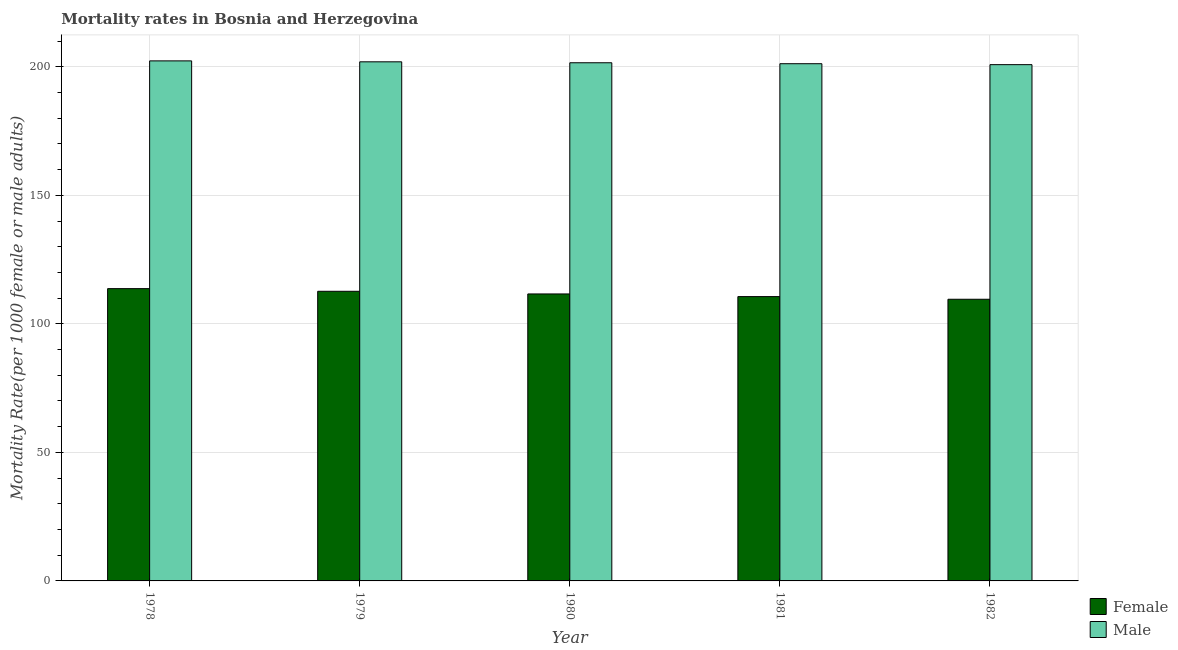How many different coloured bars are there?
Offer a terse response. 2. What is the label of the 4th group of bars from the left?
Give a very brief answer. 1981. In how many cases, is the number of bars for a given year not equal to the number of legend labels?
Offer a terse response. 0. What is the male mortality rate in 1978?
Your answer should be compact. 202.32. Across all years, what is the maximum female mortality rate?
Offer a very short reply. 113.71. Across all years, what is the minimum male mortality rate?
Your answer should be very brief. 200.85. In which year was the male mortality rate maximum?
Make the answer very short. 1978. What is the total male mortality rate in the graph?
Ensure brevity in your answer.  1007.91. What is the difference between the female mortality rate in 1978 and that in 1979?
Offer a terse response. 1.03. What is the difference between the male mortality rate in 1981 and the female mortality rate in 1979?
Ensure brevity in your answer.  -0.73. What is the average male mortality rate per year?
Your answer should be very brief. 201.58. In the year 1982, what is the difference between the female mortality rate and male mortality rate?
Provide a succinct answer. 0. What is the ratio of the female mortality rate in 1978 to that in 1980?
Your response must be concise. 1.02. Is the female mortality rate in 1978 less than that in 1979?
Offer a very short reply. No. What is the difference between the highest and the second highest male mortality rate?
Your response must be concise. 0.37. What is the difference between the highest and the lowest female mortality rate?
Provide a succinct answer. 4.13. In how many years, is the female mortality rate greater than the average female mortality rate taken over all years?
Your response must be concise. 3. Is the sum of the male mortality rate in 1981 and 1982 greater than the maximum female mortality rate across all years?
Your response must be concise. Yes. What does the 1st bar from the right in 1979 represents?
Make the answer very short. Male. How many bars are there?
Offer a terse response. 10. Are all the bars in the graph horizontal?
Make the answer very short. No. What is the difference between two consecutive major ticks on the Y-axis?
Make the answer very short. 50. Where does the legend appear in the graph?
Provide a succinct answer. Bottom right. How many legend labels are there?
Your response must be concise. 2. What is the title of the graph?
Ensure brevity in your answer.  Mortality rates in Bosnia and Herzegovina. Does "Secondary education" appear as one of the legend labels in the graph?
Provide a short and direct response. No. What is the label or title of the Y-axis?
Provide a succinct answer. Mortality Rate(per 1000 female or male adults). What is the Mortality Rate(per 1000 female or male adults) of Female in 1978?
Your answer should be very brief. 113.71. What is the Mortality Rate(per 1000 female or male adults) of Male in 1978?
Make the answer very short. 202.32. What is the Mortality Rate(per 1000 female or male adults) of Female in 1979?
Offer a terse response. 112.68. What is the Mortality Rate(per 1000 female or male adults) of Male in 1979?
Give a very brief answer. 201.95. What is the Mortality Rate(per 1000 female or male adults) in Female in 1980?
Give a very brief answer. 111.64. What is the Mortality Rate(per 1000 female or male adults) of Male in 1980?
Your answer should be very brief. 201.58. What is the Mortality Rate(per 1000 female or male adults) of Female in 1981?
Your answer should be compact. 110.61. What is the Mortality Rate(per 1000 female or male adults) in Male in 1981?
Your response must be concise. 201.22. What is the Mortality Rate(per 1000 female or male adults) of Female in 1982?
Provide a short and direct response. 109.58. What is the Mortality Rate(per 1000 female or male adults) in Male in 1982?
Make the answer very short. 200.85. Across all years, what is the maximum Mortality Rate(per 1000 female or male adults) of Female?
Give a very brief answer. 113.71. Across all years, what is the maximum Mortality Rate(per 1000 female or male adults) in Male?
Offer a very short reply. 202.32. Across all years, what is the minimum Mortality Rate(per 1000 female or male adults) of Female?
Ensure brevity in your answer.  109.58. Across all years, what is the minimum Mortality Rate(per 1000 female or male adults) in Male?
Give a very brief answer. 200.85. What is the total Mortality Rate(per 1000 female or male adults) in Female in the graph?
Make the answer very short. 558.22. What is the total Mortality Rate(per 1000 female or male adults) of Male in the graph?
Provide a short and direct response. 1007.91. What is the difference between the Mortality Rate(per 1000 female or male adults) of Female in 1978 and that in 1979?
Offer a terse response. 1.03. What is the difference between the Mortality Rate(per 1000 female or male adults) in Male in 1978 and that in 1979?
Provide a short and direct response. 0.37. What is the difference between the Mortality Rate(per 1000 female or male adults) of Female in 1978 and that in 1980?
Give a very brief answer. 2.06. What is the difference between the Mortality Rate(per 1000 female or male adults) of Male in 1978 and that in 1980?
Provide a succinct answer. 0.73. What is the difference between the Mortality Rate(per 1000 female or male adults) in Female in 1978 and that in 1981?
Provide a succinct answer. 3.1. What is the difference between the Mortality Rate(per 1000 female or male adults) in Male in 1978 and that in 1981?
Your answer should be compact. 1.1. What is the difference between the Mortality Rate(per 1000 female or male adults) in Female in 1978 and that in 1982?
Your answer should be very brief. 4.13. What is the difference between the Mortality Rate(per 1000 female or male adults) of Male in 1978 and that in 1982?
Your response must be concise. 1.47. What is the difference between the Mortality Rate(per 1000 female or male adults) of Female in 1979 and that in 1980?
Ensure brevity in your answer.  1.03. What is the difference between the Mortality Rate(per 1000 female or male adults) in Male in 1979 and that in 1980?
Provide a succinct answer. 0.37. What is the difference between the Mortality Rate(per 1000 female or male adults) of Female in 1979 and that in 1981?
Offer a very short reply. 2.06. What is the difference between the Mortality Rate(per 1000 female or male adults) in Male in 1979 and that in 1981?
Offer a terse response. 0.73. What is the difference between the Mortality Rate(per 1000 female or male adults) of Female in 1979 and that in 1982?
Offer a terse response. 3.1. What is the difference between the Mortality Rate(per 1000 female or male adults) of Male in 1979 and that in 1982?
Offer a very short reply. 1.1. What is the difference between the Mortality Rate(per 1000 female or male adults) in Female in 1980 and that in 1981?
Offer a very short reply. 1.03. What is the difference between the Mortality Rate(per 1000 female or male adults) in Male in 1980 and that in 1981?
Your answer should be very brief. 0.37. What is the difference between the Mortality Rate(per 1000 female or male adults) of Female in 1980 and that in 1982?
Ensure brevity in your answer.  2.07. What is the difference between the Mortality Rate(per 1000 female or male adults) of Male in 1980 and that in 1982?
Give a very brief answer. 0.73. What is the difference between the Mortality Rate(per 1000 female or male adults) of Female in 1981 and that in 1982?
Provide a succinct answer. 1.03. What is the difference between the Mortality Rate(per 1000 female or male adults) in Male in 1981 and that in 1982?
Ensure brevity in your answer.  0.37. What is the difference between the Mortality Rate(per 1000 female or male adults) in Female in 1978 and the Mortality Rate(per 1000 female or male adults) in Male in 1979?
Give a very brief answer. -88.24. What is the difference between the Mortality Rate(per 1000 female or male adults) of Female in 1978 and the Mortality Rate(per 1000 female or male adults) of Male in 1980?
Give a very brief answer. -87.87. What is the difference between the Mortality Rate(per 1000 female or male adults) in Female in 1978 and the Mortality Rate(per 1000 female or male adults) in Male in 1981?
Your answer should be compact. -87.51. What is the difference between the Mortality Rate(per 1000 female or male adults) of Female in 1978 and the Mortality Rate(per 1000 female or male adults) of Male in 1982?
Ensure brevity in your answer.  -87.14. What is the difference between the Mortality Rate(per 1000 female or male adults) of Female in 1979 and the Mortality Rate(per 1000 female or male adults) of Male in 1980?
Offer a terse response. -88.91. What is the difference between the Mortality Rate(per 1000 female or male adults) of Female in 1979 and the Mortality Rate(per 1000 female or male adults) of Male in 1981?
Provide a succinct answer. -88.54. What is the difference between the Mortality Rate(per 1000 female or male adults) in Female in 1979 and the Mortality Rate(per 1000 female or male adults) in Male in 1982?
Offer a very short reply. -88.17. What is the difference between the Mortality Rate(per 1000 female or male adults) in Female in 1980 and the Mortality Rate(per 1000 female or male adults) in Male in 1981?
Offer a very short reply. -89.57. What is the difference between the Mortality Rate(per 1000 female or male adults) in Female in 1980 and the Mortality Rate(per 1000 female or male adults) in Male in 1982?
Your response must be concise. -89.2. What is the difference between the Mortality Rate(per 1000 female or male adults) of Female in 1981 and the Mortality Rate(per 1000 female or male adults) of Male in 1982?
Give a very brief answer. -90.24. What is the average Mortality Rate(per 1000 female or male adults) in Female per year?
Your answer should be compact. 111.64. What is the average Mortality Rate(per 1000 female or male adults) of Male per year?
Provide a succinct answer. 201.58. In the year 1978, what is the difference between the Mortality Rate(per 1000 female or male adults) in Female and Mortality Rate(per 1000 female or male adults) in Male?
Provide a short and direct response. -88.61. In the year 1979, what is the difference between the Mortality Rate(per 1000 female or male adults) in Female and Mortality Rate(per 1000 female or male adults) in Male?
Keep it short and to the point. -89.27. In the year 1980, what is the difference between the Mortality Rate(per 1000 female or male adults) of Female and Mortality Rate(per 1000 female or male adults) of Male?
Your response must be concise. -89.94. In the year 1981, what is the difference between the Mortality Rate(per 1000 female or male adults) in Female and Mortality Rate(per 1000 female or male adults) in Male?
Give a very brief answer. -90.6. In the year 1982, what is the difference between the Mortality Rate(per 1000 female or male adults) in Female and Mortality Rate(per 1000 female or male adults) in Male?
Give a very brief answer. -91.27. What is the ratio of the Mortality Rate(per 1000 female or male adults) of Female in 1978 to that in 1979?
Offer a very short reply. 1.01. What is the ratio of the Mortality Rate(per 1000 female or male adults) of Male in 1978 to that in 1979?
Your answer should be compact. 1. What is the ratio of the Mortality Rate(per 1000 female or male adults) of Female in 1978 to that in 1980?
Provide a succinct answer. 1.02. What is the ratio of the Mortality Rate(per 1000 female or male adults) in Female in 1978 to that in 1981?
Provide a short and direct response. 1.03. What is the ratio of the Mortality Rate(per 1000 female or male adults) in Female in 1978 to that in 1982?
Ensure brevity in your answer.  1.04. What is the ratio of the Mortality Rate(per 1000 female or male adults) of Male in 1978 to that in 1982?
Offer a very short reply. 1.01. What is the ratio of the Mortality Rate(per 1000 female or male adults) in Female in 1979 to that in 1980?
Offer a very short reply. 1.01. What is the ratio of the Mortality Rate(per 1000 female or male adults) in Male in 1979 to that in 1980?
Offer a very short reply. 1. What is the ratio of the Mortality Rate(per 1000 female or male adults) of Female in 1979 to that in 1981?
Provide a succinct answer. 1.02. What is the ratio of the Mortality Rate(per 1000 female or male adults) in Female in 1979 to that in 1982?
Make the answer very short. 1.03. What is the ratio of the Mortality Rate(per 1000 female or male adults) in Female in 1980 to that in 1981?
Keep it short and to the point. 1.01. What is the ratio of the Mortality Rate(per 1000 female or male adults) in Male in 1980 to that in 1981?
Offer a very short reply. 1. What is the ratio of the Mortality Rate(per 1000 female or male adults) of Female in 1980 to that in 1982?
Your answer should be very brief. 1.02. What is the ratio of the Mortality Rate(per 1000 female or male adults) in Male in 1980 to that in 1982?
Give a very brief answer. 1. What is the ratio of the Mortality Rate(per 1000 female or male adults) of Female in 1981 to that in 1982?
Make the answer very short. 1.01. What is the ratio of the Mortality Rate(per 1000 female or male adults) in Male in 1981 to that in 1982?
Keep it short and to the point. 1. What is the difference between the highest and the second highest Mortality Rate(per 1000 female or male adults) of Female?
Provide a succinct answer. 1.03. What is the difference between the highest and the second highest Mortality Rate(per 1000 female or male adults) in Male?
Keep it short and to the point. 0.37. What is the difference between the highest and the lowest Mortality Rate(per 1000 female or male adults) of Female?
Offer a very short reply. 4.13. What is the difference between the highest and the lowest Mortality Rate(per 1000 female or male adults) of Male?
Offer a very short reply. 1.47. 